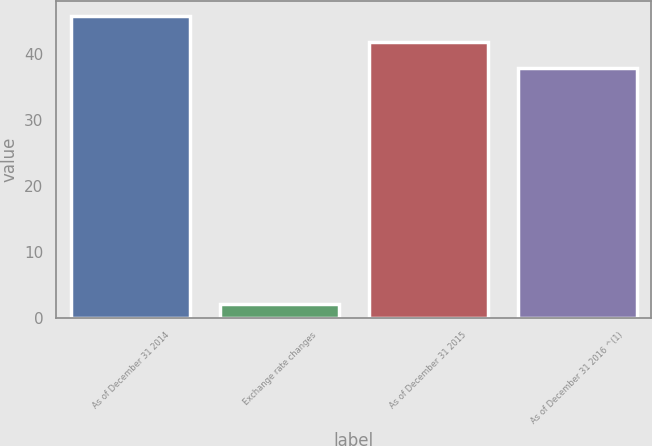<chart> <loc_0><loc_0><loc_500><loc_500><bar_chart><fcel>As of December 31 2014<fcel>Exchange rate changes<fcel>As of December 31 2015<fcel>As of December 31 2016 ^(1)<nl><fcel>45.8<fcel>2<fcel>41.9<fcel>38<nl></chart> 